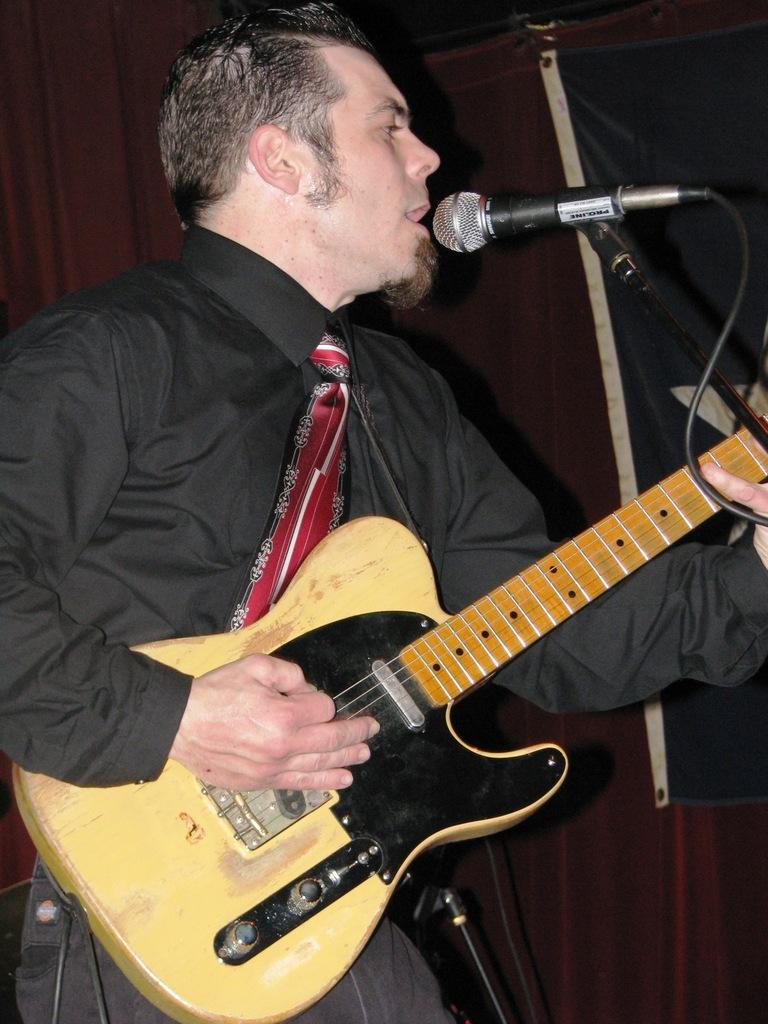What is the man in the image doing? The man is holding a guitar and singing into a microphone. What object is the man holding in the image? The man is holding a guitar. What is the man using to amplify his voice in the image? The man is singing into a microphone. How many chairs are visible in the image? There are no chairs visible in the image; it only features a man holding a guitar and singing into a microphone. 